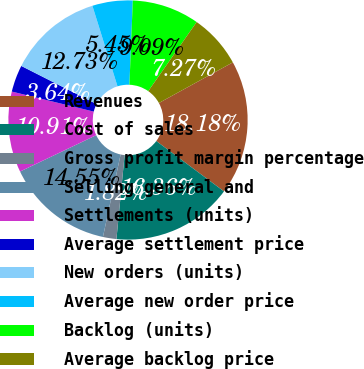Convert chart to OTSL. <chart><loc_0><loc_0><loc_500><loc_500><pie_chart><fcel>Revenues<fcel>Cost of sales<fcel>Gross profit margin percentage<fcel>Selling general and<fcel>Settlements (units)<fcel>Average settlement price<fcel>New orders (units)<fcel>Average new order price<fcel>Backlog (units)<fcel>Average backlog price<nl><fcel>18.18%<fcel>16.36%<fcel>1.82%<fcel>14.55%<fcel>10.91%<fcel>3.64%<fcel>12.73%<fcel>5.45%<fcel>9.09%<fcel>7.27%<nl></chart> 